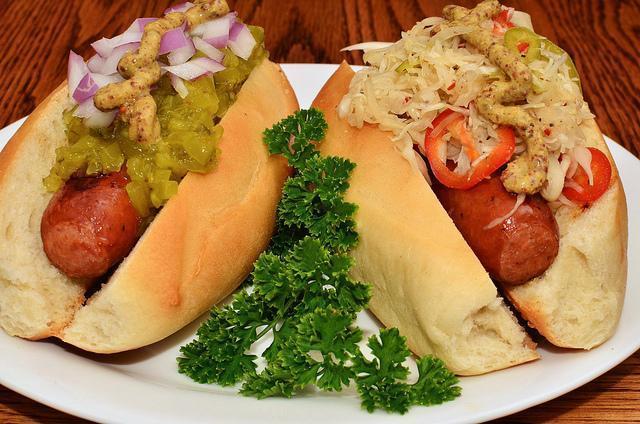How many hot dogs are there?
Give a very brief answer. 2. How many carrots are in the picture?
Give a very brief answer. 2. How many motorcycles can be seen?
Give a very brief answer. 0. 